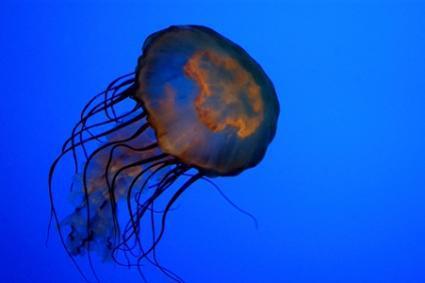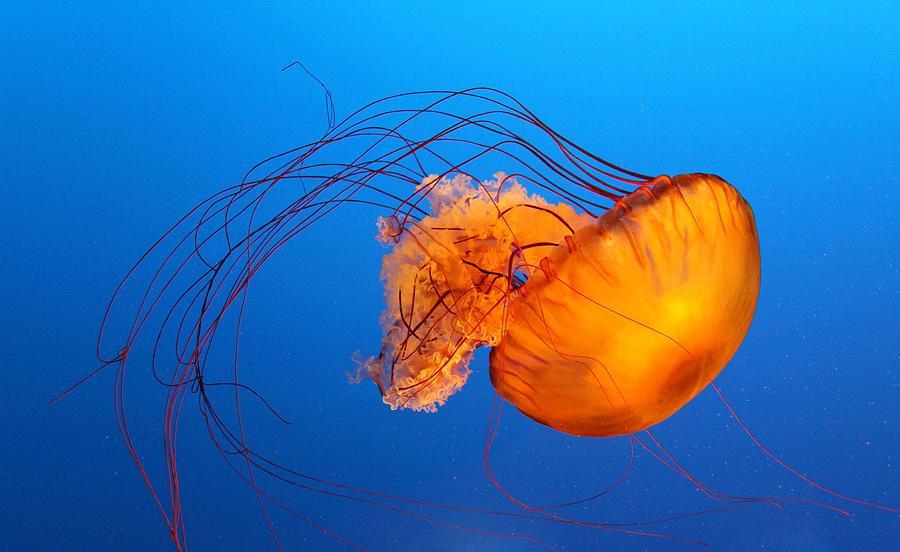The first image is the image on the left, the second image is the image on the right. Considering the images on both sides, is "The right-hand jellyfish appears tilted down, with its """"cap"""" going  rightward." valid? Answer yes or no. Yes. 